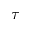<formula> <loc_0><loc_0><loc_500><loc_500>\tau</formula> 